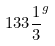Convert formula to latex. <formula><loc_0><loc_0><loc_500><loc_500>1 3 3 { \frac { 1 } { 3 } } ^ { g }</formula> 